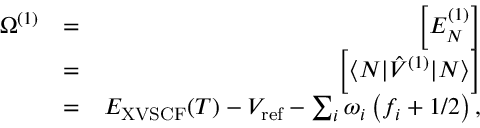<formula> <loc_0><loc_0><loc_500><loc_500>\begin{array} { r l r } { \Omega ^ { ( 1 ) } } & { = } & { \left [ E _ { N } ^ { ( 1 ) } \right ] } \\ & { = } & { \left [ \langle N | \hat { V } ^ { ( 1 ) } | N \rangle \right ] } \\ & { = } & { E _ { X V S C F } ( T ) - V _ { r e f } - \sum _ { i } { \omega } _ { i } \left ( f _ { i } + { 1 } / { 2 } \right ) , } \end{array}</formula> 